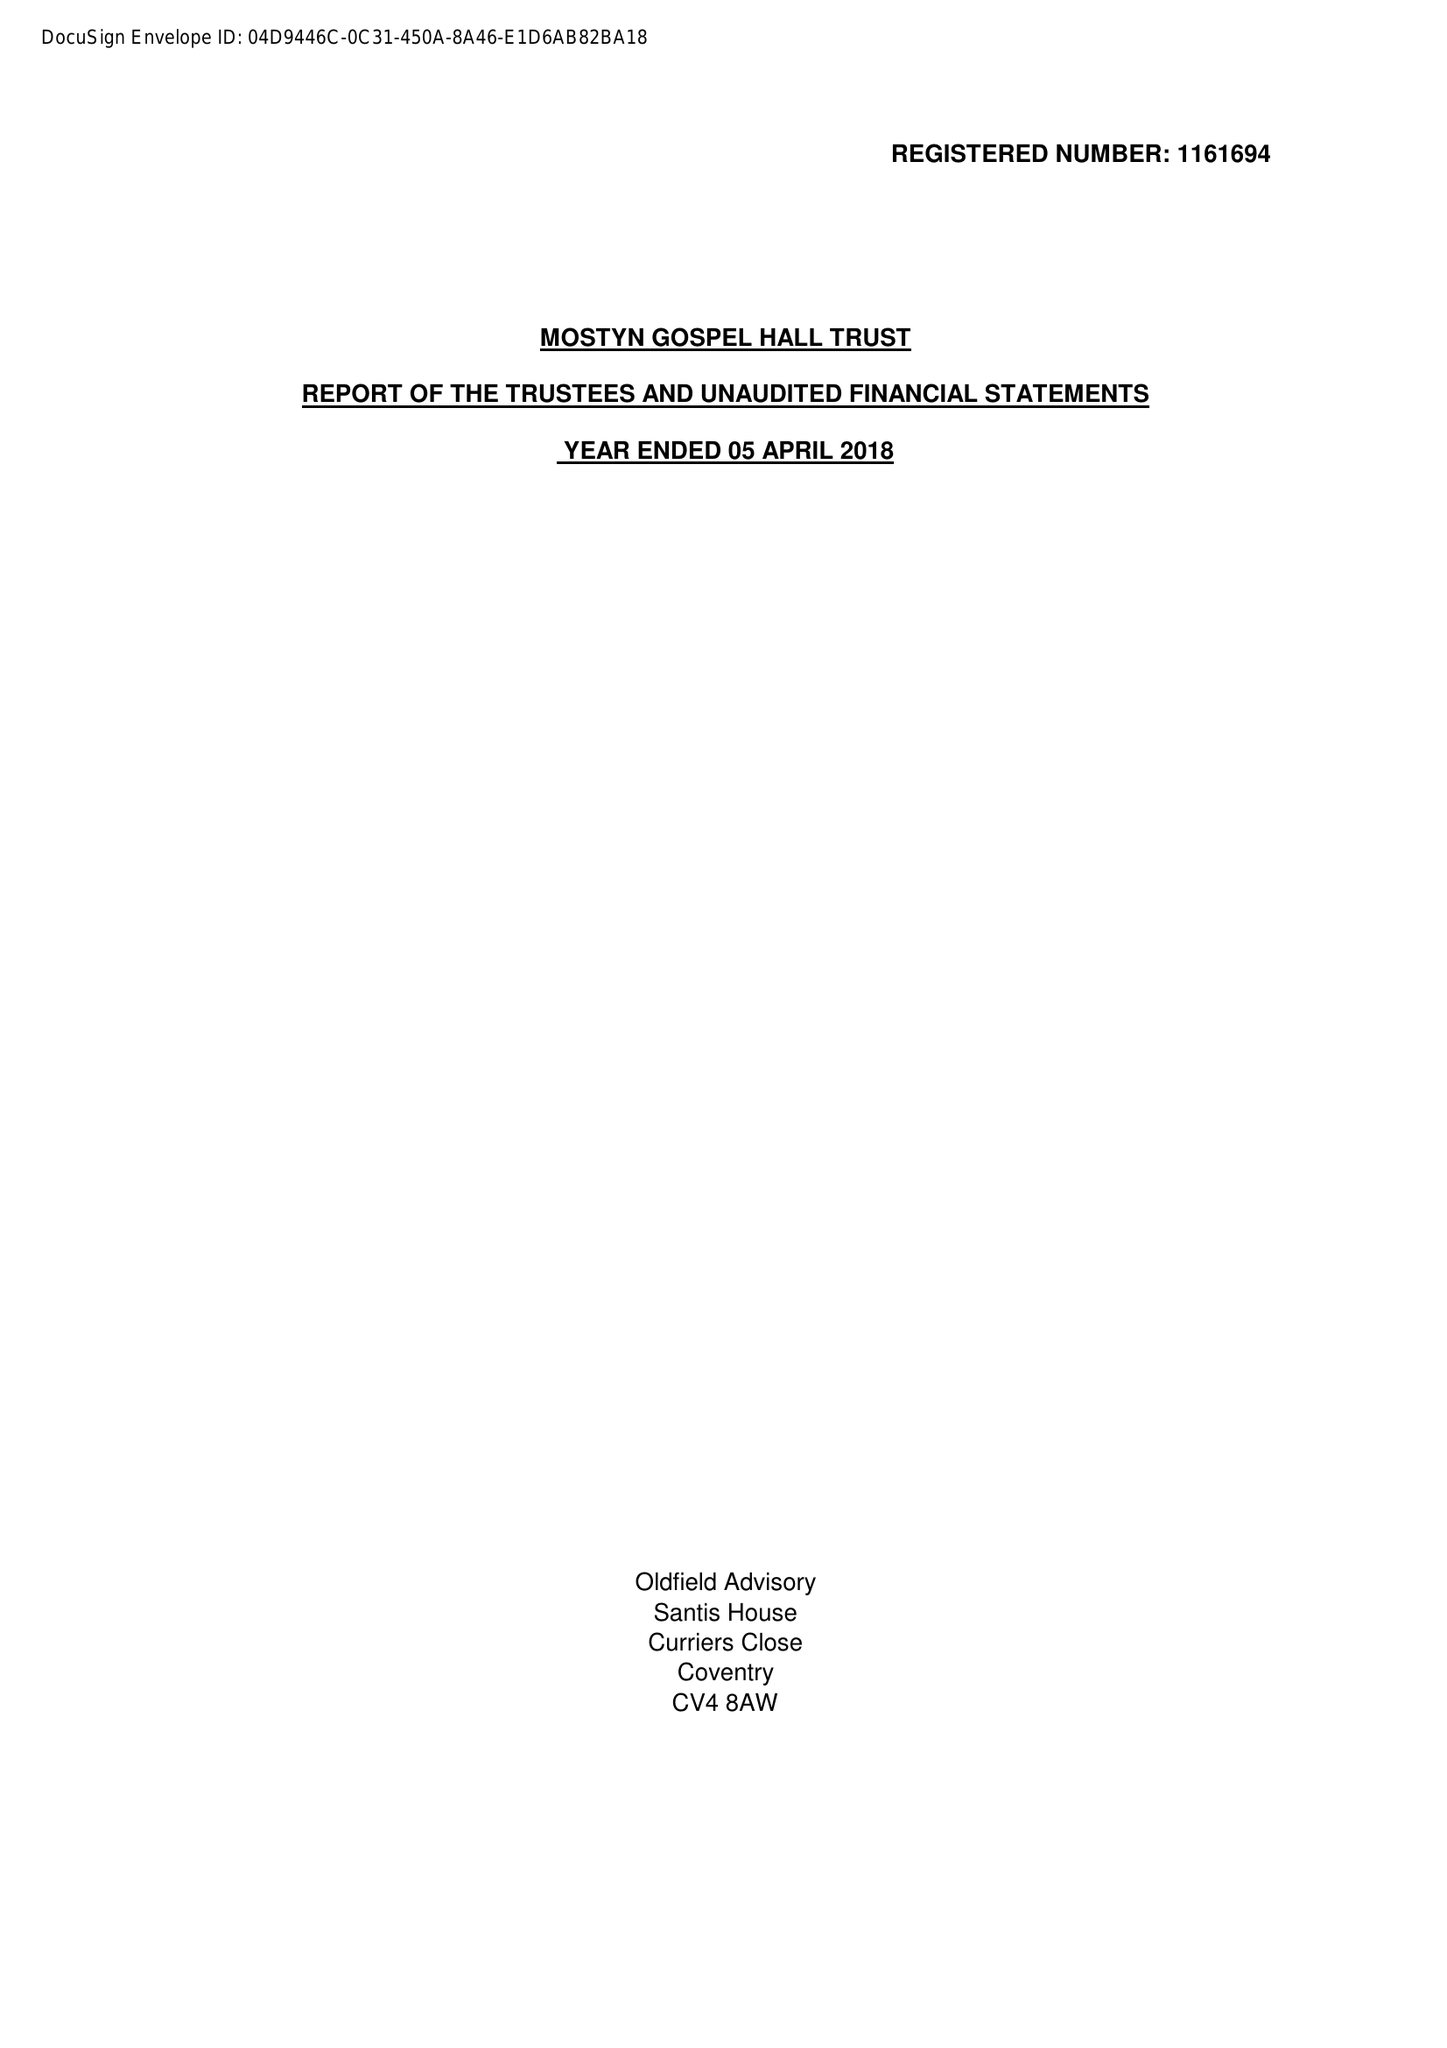What is the value for the address__post_town?
Answer the question using a single word or phrase. LEICESTER 